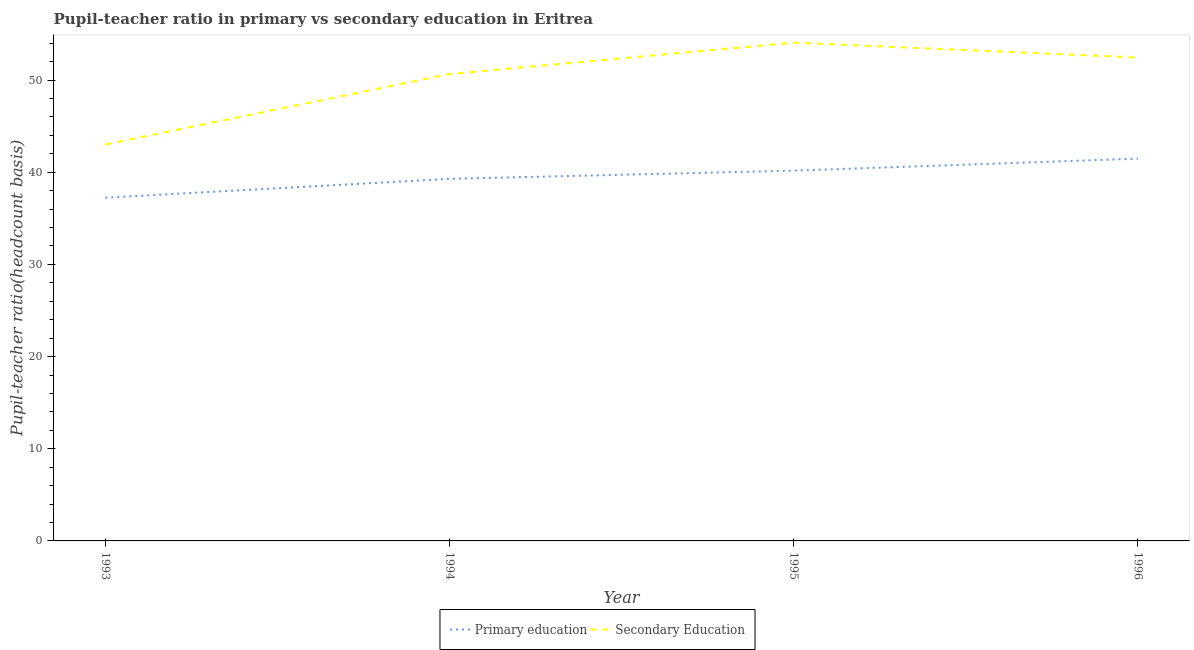Is the number of lines equal to the number of legend labels?
Offer a very short reply. Yes. What is the pupil teacher ratio on secondary education in 1996?
Your response must be concise. 52.44. Across all years, what is the maximum pupil-teacher ratio in primary education?
Make the answer very short. 41.48. Across all years, what is the minimum pupil teacher ratio on secondary education?
Your answer should be compact. 43.02. What is the total pupil-teacher ratio in primary education in the graph?
Make the answer very short. 158.17. What is the difference between the pupil-teacher ratio in primary education in 1993 and that in 1994?
Offer a terse response. -2.04. What is the difference between the pupil-teacher ratio in primary education in 1996 and the pupil teacher ratio on secondary education in 1995?
Offer a terse response. -12.59. What is the average pupil-teacher ratio in primary education per year?
Make the answer very short. 39.54. In the year 1996, what is the difference between the pupil teacher ratio on secondary education and pupil-teacher ratio in primary education?
Offer a terse response. 10.97. In how many years, is the pupil-teacher ratio in primary education greater than 20?
Your answer should be compact. 4. What is the ratio of the pupil-teacher ratio in primary education in 1993 to that in 1994?
Offer a very short reply. 0.95. What is the difference between the highest and the second highest pupil-teacher ratio in primary education?
Your answer should be compact. 1.3. What is the difference between the highest and the lowest pupil teacher ratio on secondary education?
Ensure brevity in your answer.  11.05. Is the sum of the pupil teacher ratio on secondary education in 1993 and 1995 greater than the maximum pupil-teacher ratio in primary education across all years?
Offer a terse response. Yes. What is the difference between two consecutive major ticks on the Y-axis?
Your answer should be compact. 10. Does the graph contain grids?
Provide a succinct answer. No. Where does the legend appear in the graph?
Provide a succinct answer. Bottom center. How many legend labels are there?
Offer a terse response. 2. What is the title of the graph?
Keep it short and to the point. Pupil-teacher ratio in primary vs secondary education in Eritrea. What is the label or title of the X-axis?
Offer a terse response. Year. What is the label or title of the Y-axis?
Offer a very short reply. Pupil-teacher ratio(headcount basis). What is the Pupil-teacher ratio(headcount basis) in Primary education in 1993?
Ensure brevity in your answer.  37.24. What is the Pupil-teacher ratio(headcount basis) in Secondary Education in 1993?
Offer a very short reply. 43.02. What is the Pupil-teacher ratio(headcount basis) in Primary education in 1994?
Provide a short and direct response. 39.28. What is the Pupil-teacher ratio(headcount basis) of Secondary Education in 1994?
Make the answer very short. 50.66. What is the Pupil-teacher ratio(headcount basis) in Primary education in 1995?
Your answer should be very brief. 40.17. What is the Pupil-teacher ratio(headcount basis) of Secondary Education in 1995?
Make the answer very short. 54.06. What is the Pupil-teacher ratio(headcount basis) of Primary education in 1996?
Offer a terse response. 41.48. What is the Pupil-teacher ratio(headcount basis) of Secondary Education in 1996?
Ensure brevity in your answer.  52.44. Across all years, what is the maximum Pupil-teacher ratio(headcount basis) in Primary education?
Provide a short and direct response. 41.48. Across all years, what is the maximum Pupil-teacher ratio(headcount basis) of Secondary Education?
Make the answer very short. 54.06. Across all years, what is the minimum Pupil-teacher ratio(headcount basis) of Primary education?
Your answer should be compact. 37.24. Across all years, what is the minimum Pupil-teacher ratio(headcount basis) in Secondary Education?
Provide a short and direct response. 43.02. What is the total Pupil-teacher ratio(headcount basis) of Primary education in the graph?
Make the answer very short. 158.17. What is the total Pupil-teacher ratio(headcount basis) in Secondary Education in the graph?
Give a very brief answer. 200.18. What is the difference between the Pupil-teacher ratio(headcount basis) in Primary education in 1993 and that in 1994?
Your response must be concise. -2.04. What is the difference between the Pupil-teacher ratio(headcount basis) in Secondary Education in 1993 and that in 1994?
Your response must be concise. -7.64. What is the difference between the Pupil-teacher ratio(headcount basis) in Primary education in 1993 and that in 1995?
Your answer should be compact. -2.93. What is the difference between the Pupil-teacher ratio(headcount basis) of Secondary Education in 1993 and that in 1995?
Offer a very short reply. -11.05. What is the difference between the Pupil-teacher ratio(headcount basis) in Primary education in 1993 and that in 1996?
Offer a very short reply. -4.24. What is the difference between the Pupil-teacher ratio(headcount basis) of Secondary Education in 1993 and that in 1996?
Your response must be concise. -9.43. What is the difference between the Pupil-teacher ratio(headcount basis) of Primary education in 1994 and that in 1995?
Give a very brief answer. -0.89. What is the difference between the Pupil-teacher ratio(headcount basis) of Secondary Education in 1994 and that in 1995?
Keep it short and to the point. -3.41. What is the difference between the Pupil-teacher ratio(headcount basis) of Primary education in 1994 and that in 1996?
Your response must be concise. -2.19. What is the difference between the Pupil-teacher ratio(headcount basis) in Secondary Education in 1994 and that in 1996?
Keep it short and to the point. -1.79. What is the difference between the Pupil-teacher ratio(headcount basis) in Primary education in 1995 and that in 1996?
Your answer should be compact. -1.3. What is the difference between the Pupil-teacher ratio(headcount basis) of Secondary Education in 1995 and that in 1996?
Make the answer very short. 1.62. What is the difference between the Pupil-teacher ratio(headcount basis) of Primary education in 1993 and the Pupil-teacher ratio(headcount basis) of Secondary Education in 1994?
Provide a succinct answer. -13.41. What is the difference between the Pupil-teacher ratio(headcount basis) in Primary education in 1993 and the Pupil-teacher ratio(headcount basis) in Secondary Education in 1995?
Ensure brevity in your answer.  -16.82. What is the difference between the Pupil-teacher ratio(headcount basis) in Primary education in 1993 and the Pupil-teacher ratio(headcount basis) in Secondary Education in 1996?
Provide a succinct answer. -15.2. What is the difference between the Pupil-teacher ratio(headcount basis) of Primary education in 1994 and the Pupil-teacher ratio(headcount basis) of Secondary Education in 1995?
Keep it short and to the point. -14.78. What is the difference between the Pupil-teacher ratio(headcount basis) of Primary education in 1994 and the Pupil-teacher ratio(headcount basis) of Secondary Education in 1996?
Give a very brief answer. -13.16. What is the difference between the Pupil-teacher ratio(headcount basis) of Primary education in 1995 and the Pupil-teacher ratio(headcount basis) of Secondary Education in 1996?
Your answer should be very brief. -12.27. What is the average Pupil-teacher ratio(headcount basis) in Primary education per year?
Give a very brief answer. 39.54. What is the average Pupil-teacher ratio(headcount basis) in Secondary Education per year?
Give a very brief answer. 50.04. In the year 1993, what is the difference between the Pupil-teacher ratio(headcount basis) in Primary education and Pupil-teacher ratio(headcount basis) in Secondary Education?
Your answer should be very brief. -5.78. In the year 1994, what is the difference between the Pupil-teacher ratio(headcount basis) in Primary education and Pupil-teacher ratio(headcount basis) in Secondary Education?
Provide a succinct answer. -11.37. In the year 1995, what is the difference between the Pupil-teacher ratio(headcount basis) in Primary education and Pupil-teacher ratio(headcount basis) in Secondary Education?
Give a very brief answer. -13.89. In the year 1996, what is the difference between the Pupil-teacher ratio(headcount basis) of Primary education and Pupil-teacher ratio(headcount basis) of Secondary Education?
Ensure brevity in your answer.  -10.97. What is the ratio of the Pupil-teacher ratio(headcount basis) in Primary education in 1993 to that in 1994?
Your response must be concise. 0.95. What is the ratio of the Pupil-teacher ratio(headcount basis) of Secondary Education in 1993 to that in 1994?
Your response must be concise. 0.85. What is the ratio of the Pupil-teacher ratio(headcount basis) of Primary education in 1993 to that in 1995?
Provide a short and direct response. 0.93. What is the ratio of the Pupil-teacher ratio(headcount basis) in Secondary Education in 1993 to that in 1995?
Give a very brief answer. 0.8. What is the ratio of the Pupil-teacher ratio(headcount basis) of Primary education in 1993 to that in 1996?
Your answer should be compact. 0.9. What is the ratio of the Pupil-teacher ratio(headcount basis) in Secondary Education in 1993 to that in 1996?
Your answer should be compact. 0.82. What is the ratio of the Pupil-teacher ratio(headcount basis) in Primary education in 1994 to that in 1995?
Offer a very short reply. 0.98. What is the ratio of the Pupil-teacher ratio(headcount basis) in Secondary Education in 1994 to that in 1995?
Your response must be concise. 0.94. What is the ratio of the Pupil-teacher ratio(headcount basis) of Primary education in 1994 to that in 1996?
Offer a very short reply. 0.95. What is the ratio of the Pupil-teacher ratio(headcount basis) of Secondary Education in 1994 to that in 1996?
Make the answer very short. 0.97. What is the ratio of the Pupil-teacher ratio(headcount basis) in Primary education in 1995 to that in 1996?
Offer a very short reply. 0.97. What is the ratio of the Pupil-teacher ratio(headcount basis) in Secondary Education in 1995 to that in 1996?
Ensure brevity in your answer.  1.03. What is the difference between the highest and the second highest Pupil-teacher ratio(headcount basis) of Primary education?
Provide a succinct answer. 1.3. What is the difference between the highest and the second highest Pupil-teacher ratio(headcount basis) in Secondary Education?
Offer a terse response. 1.62. What is the difference between the highest and the lowest Pupil-teacher ratio(headcount basis) of Primary education?
Offer a very short reply. 4.24. What is the difference between the highest and the lowest Pupil-teacher ratio(headcount basis) of Secondary Education?
Ensure brevity in your answer.  11.05. 